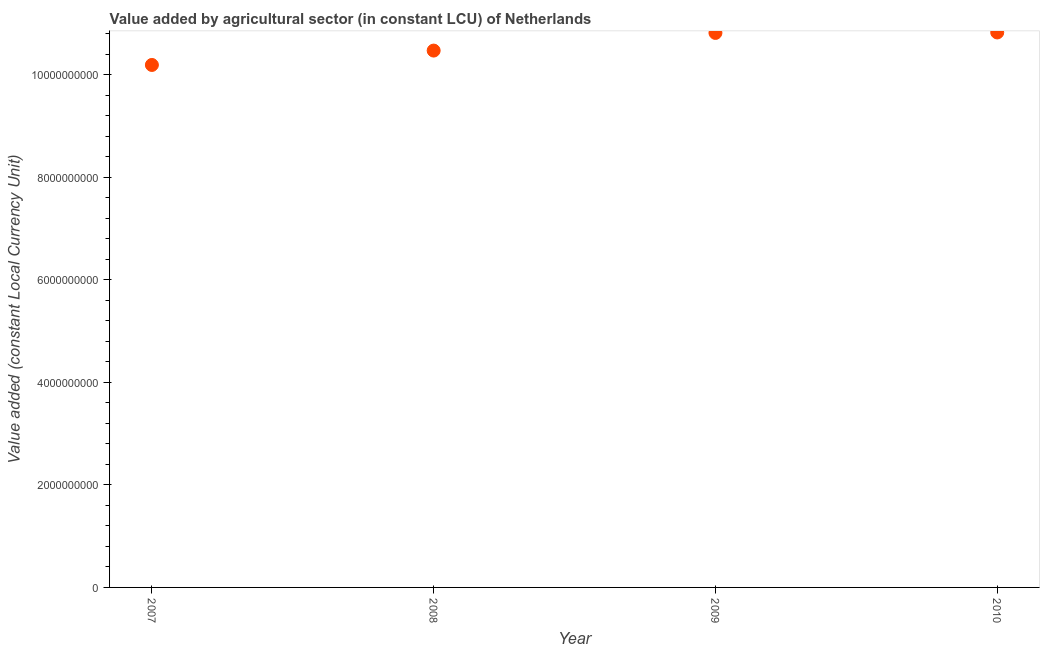What is the value added by agriculture sector in 2009?
Keep it short and to the point. 1.08e+1. Across all years, what is the maximum value added by agriculture sector?
Your response must be concise. 1.08e+1. Across all years, what is the minimum value added by agriculture sector?
Offer a very short reply. 1.02e+1. In which year was the value added by agriculture sector minimum?
Keep it short and to the point. 2007. What is the sum of the value added by agriculture sector?
Give a very brief answer. 4.23e+1. What is the difference between the value added by agriculture sector in 2007 and 2010?
Your answer should be very brief. -6.34e+08. What is the average value added by agriculture sector per year?
Make the answer very short. 1.06e+1. What is the median value added by agriculture sector?
Your response must be concise. 1.06e+1. In how many years, is the value added by agriculture sector greater than 3200000000 LCU?
Make the answer very short. 4. What is the ratio of the value added by agriculture sector in 2008 to that in 2009?
Give a very brief answer. 0.97. What is the difference between the highest and the second highest value added by agriculture sector?
Your answer should be very brief. 9.42e+06. What is the difference between the highest and the lowest value added by agriculture sector?
Keep it short and to the point. 6.34e+08. How many dotlines are there?
Ensure brevity in your answer.  1. How many years are there in the graph?
Provide a short and direct response. 4. What is the difference between two consecutive major ticks on the Y-axis?
Provide a short and direct response. 2.00e+09. Does the graph contain any zero values?
Your answer should be compact. No. What is the title of the graph?
Provide a short and direct response. Value added by agricultural sector (in constant LCU) of Netherlands. What is the label or title of the Y-axis?
Keep it short and to the point. Value added (constant Local Currency Unit). What is the Value added (constant Local Currency Unit) in 2007?
Ensure brevity in your answer.  1.02e+1. What is the Value added (constant Local Currency Unit) in 2008?
Make the answer very short. 1.05e+1. What is the Value added (constant Local Currency Unit) in 2009?
Keep it short and to the point. 1.08e+1. What is the Value added (constant Local Currency Unit) in 2010?
Offer a terse response. 1.08e+1. What is the difference between the Value added (constant Local Currency Unit) in 2007 and 2008?
Keep it short and to the point. -2.80e+08. What is the difference between the Value added (constant Local Currency Unit) in 2007 and 2009?
Make the answer very short. -6.25e+08. What is the difference between the Value added (constant Local Currency Unit) in 2007 and 2010?
Your answer should be compact. -6.34e+08. What is the difference between the Value added (constant Local Currency Unit) in 2008 and 2009?
Ensure brevity in your answer.  -3.44e+08. What is the difference between the Value added (constant Local Currency Unit) in 2008 and 2010?
Keep it short and to the point. -3.54e+08. What is the difference between the Value added (constant Local Currency Unit) in 2009 and 2010?
Offer a very short reply. -9.42e+06. What is the ratio of the Value added (constant Local Currency Unit) in 2007 to that in 2008?
Your response must be concise. 0.97. What is the ratio of the Value added (constant Local Currency Unit) in 2007 to that in 2009?
Your answer should be very brief. 0.94. What is the ratio of the Value added (constant Local Currency Unit) in 2007 to that in 2010?
Offer a terse response. 0.94. What is the ratio of the Value added (constant Local Currency Unit) in 2009 to that in 2010?
Offer a very short reply. 1. 